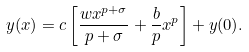<formula> <loc_0><loc_0><loc_500><loc_500>y ( x ) = c \left [ \frac { w x ^ { p + \sigma } } { p + \sigma } + \frac { b } { p } x ^ { p } \right ] + y ( 0 ) .</formula> 